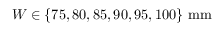Convert formula to latex. <formula><loc_0><loc_0><loc_500><loc_500>W \in \{ 7 5 , 8 0 , 8 5 , 9 0 , 9 5 , 1 0 0 \} \ m m</formula> 